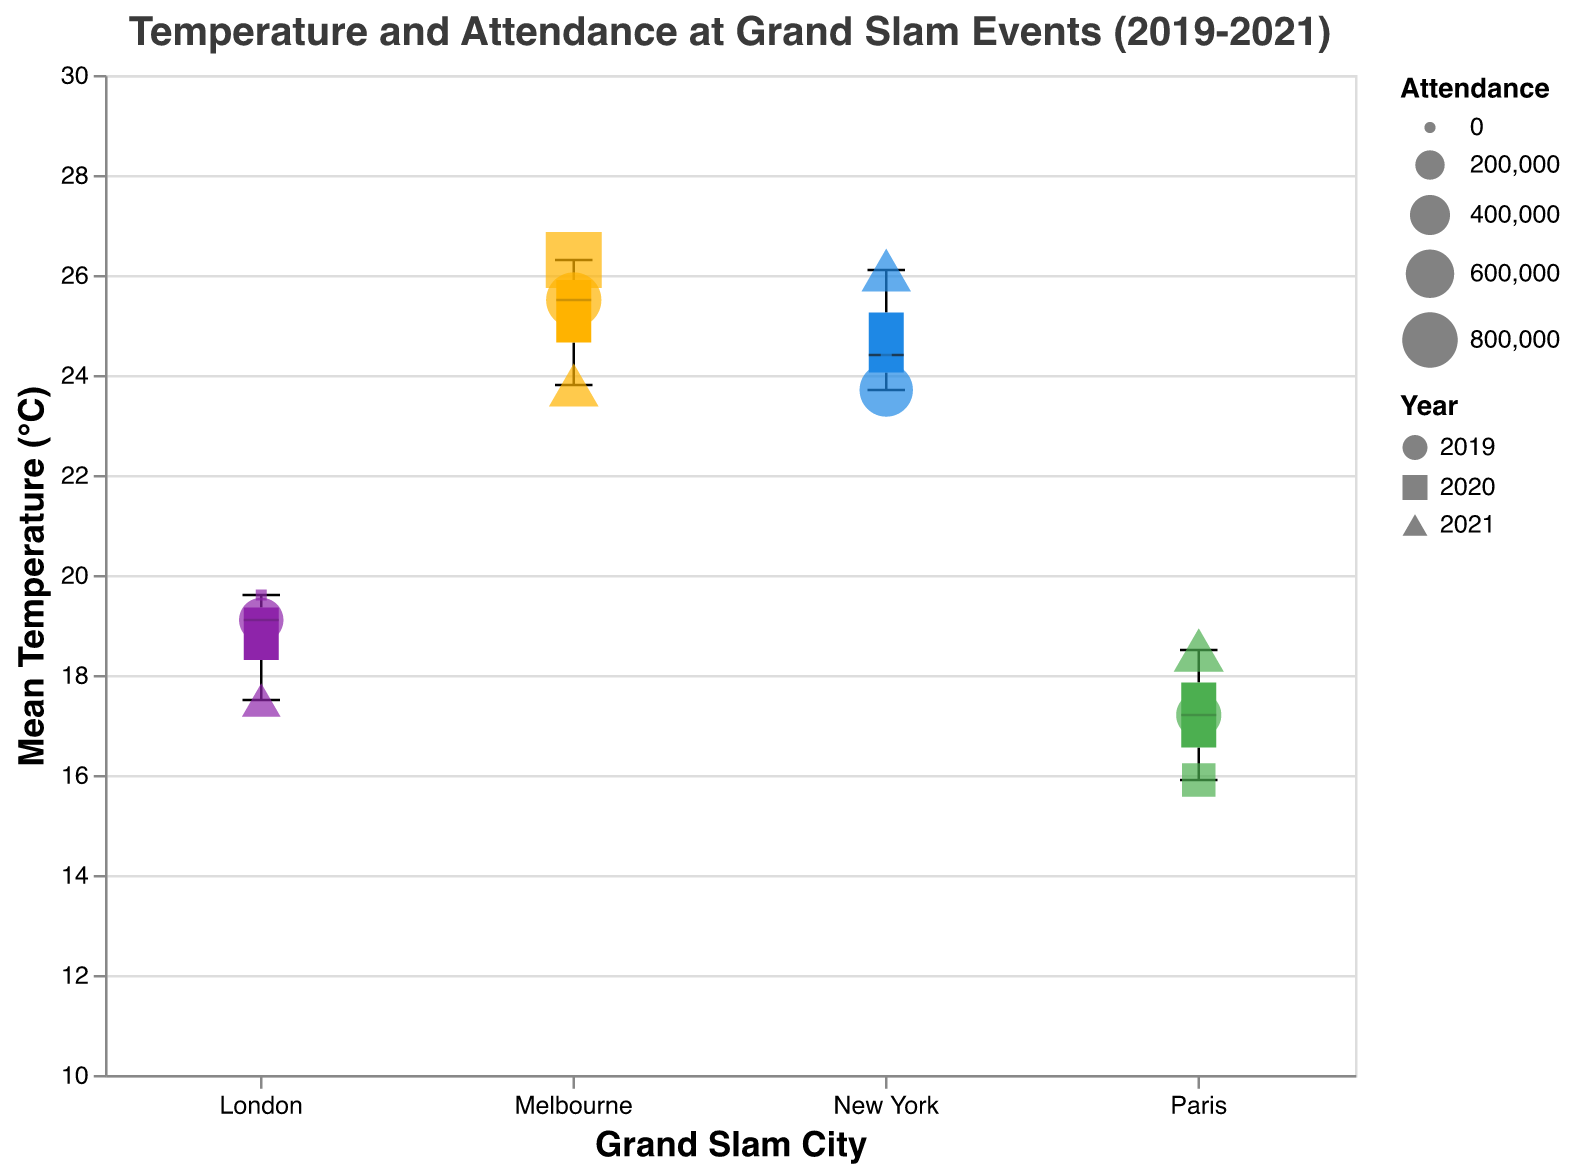What is the title of the figure? The title is located at the top of the chart and it serves to provide a brief description of what is illustrated in the figure. In this case, it reads "Temperature and Attendance at Grand Slam Events (2019-2021)"
Answer: Temperature and Attendance at Grand Slam Events (2019-2021) Which city recorded the highest mean temperature? Looking at the y-axis representing mean temperature, find the scatter point with the highest value. In this figure, New York has the scatter point highest up on the y-axis at around 26.1°C in 2021.
Answer: New York What is the mean temperature range for Melbourne? Locate the box representing Melbourne on the x-axis and then identify the minimum and maximum whiskers of the boxplot. The temperature range spans from 23.8°C to 26.3°C.
Answer: 23.8°C to 26.3°C How does the attendance for the Australian Open in 2021 compare with 2020? Look at the scatter points marked for Melbourne. In 2020, the attendance was 812,000 and in 2021, it was 639,000. To compare, 2020 had a higher attendance than 2021.
Answer: Higher in 2020 What shape represents the 2020 data points? Each year is represented by a unique shape in the scatter plot. Check the legend to find the shape corresponding to 2020. It is represented by a specific shape in the legend.
Answer: Square (Note: Adjust answer based on shapes used in actual figure) Which city had the lowest event attendance, and for what year? Identify the scatter points with the smallest size. The smallest data points represent lowest attendance. The smallest point appears in London at 0 attendance in 2020 due to event cancellation.
Answer: London, 2020 What is the mean temperature difference between the French Open in May 2019 and September 2020? Identify the scatter points for the French Open in May 2019 and September 2020, then subtract the two temperatures. The difference is 17.2°C - 15.9°C = 1.3°C.
Answer: 1.3°C Which event had the highest attendance, and what was the value? Compare the sizes of the scatter points. The largest scatter point represents the highest attendance. It is for the Australian Open in Melbourne in 2020 with an attendance of 812,000.
Answer: Australian Open, 812,000 How does the median temperature for Wimbledon compare to the French Open? Look at the boxplot for Wimbledon and French Open. The median is represented by the dark line in the box. Wimbledon median temperature is around 19.1°C and French Open around 17.2°C. Wimbledon has a higher median temperature.
Answer: Wimbledon is higher What is the mean attendance for the US Open over the three years? Find the attendance values for New York each year (737,872 in 2019, 0 in 2020, 631,387 in 2021). Sum these values and divide by three: (737872 + 0 + 631387) / 3 = 456,419.67
Answer: About 456,420 